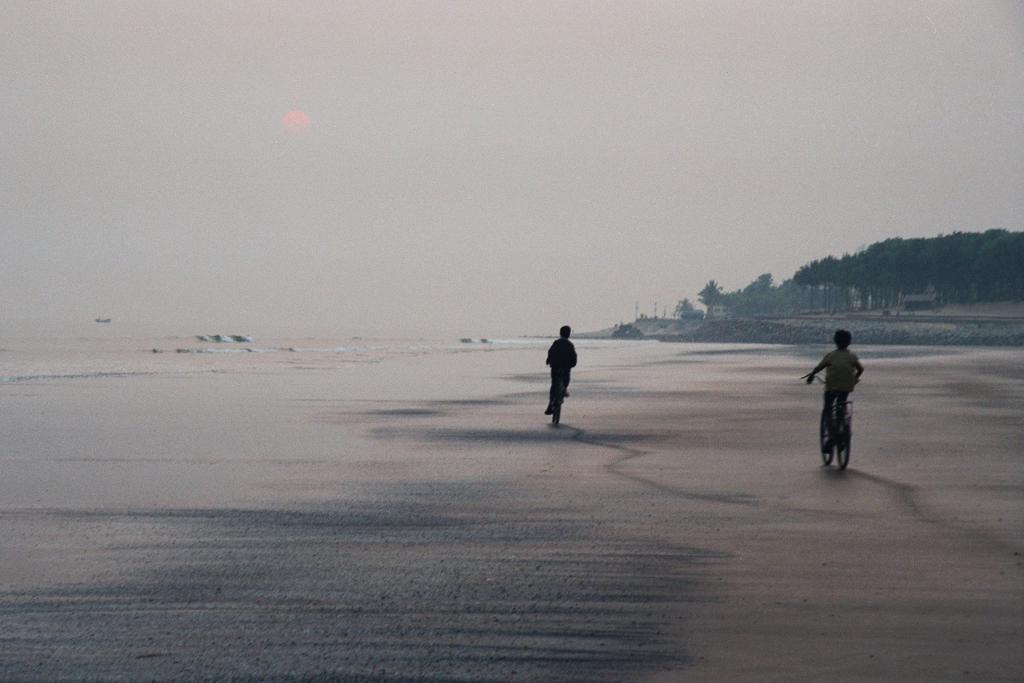Describe this image in one or two sentences. In the foreground I can see two persons are riding a bicycle on the beach and water. In the background I can see fence, trees, buildings, vehicles and the sky. This image is taken may be on the sandy beach. 